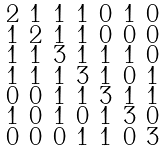Convert formula to latex. <formula><loc_0><loc_0><loc_500><loc_500>\begin{smallmatrix} 2 & 1 & 1 & 1 & 0 & 1 & 0 \\ 1 & 2 & 1 & 1 & 0 & 0 & 0 \\ 1 & 1 & 3 & 1 & 1 & 1 & 0 \\ 1 & 1 & 1 & 3 & 1 & 0 & 1 \\ 0 & 0 & 1 & 1 & 3 & 1 & 1 \\ 1 & 0 & 1 & 0 & 1 & 3 & 0 \\ 0 & 0 & 0 & 1 & 1 & 0 & 3 \end{smallmatrix}</formula> 